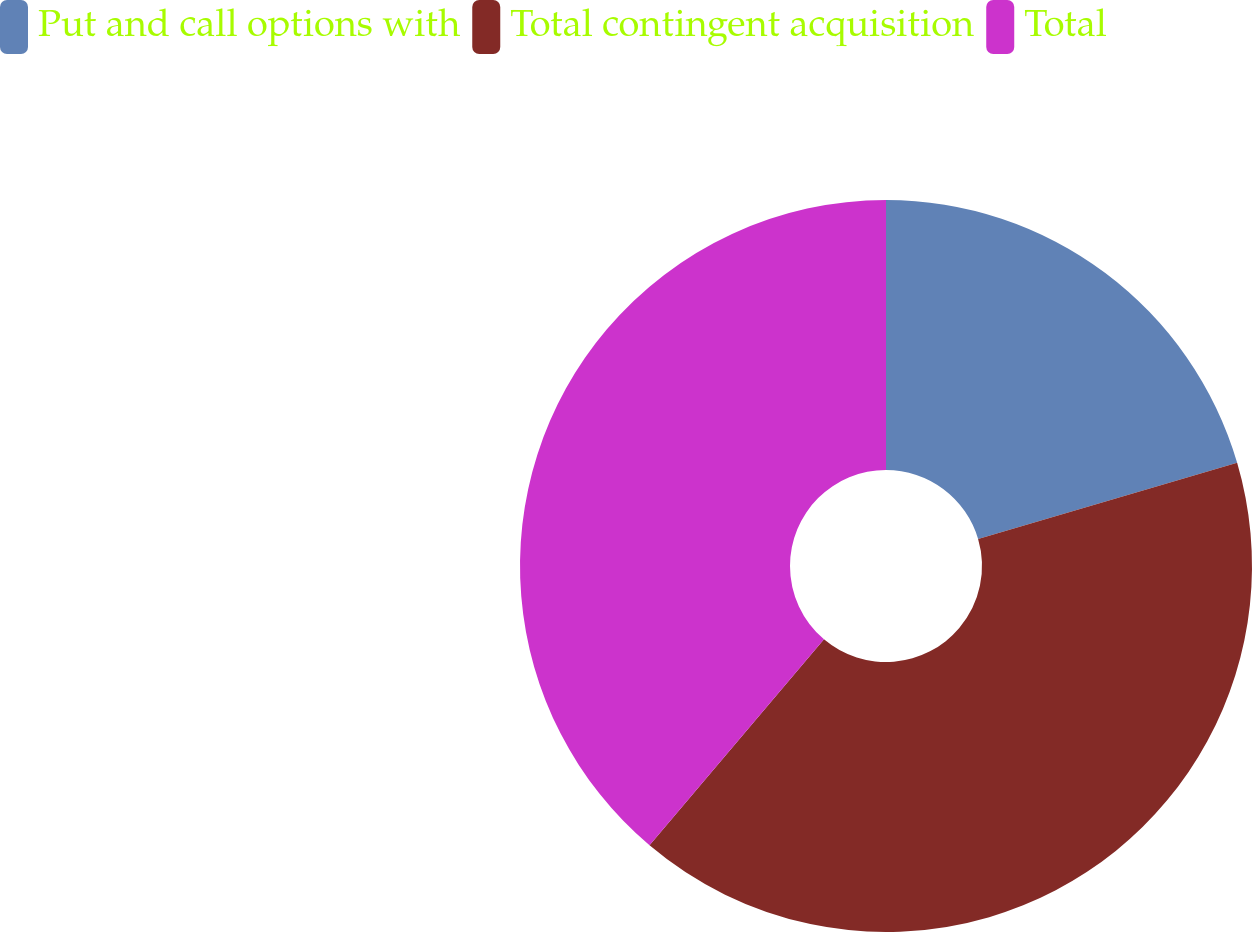Convert chart to OTSL. <chart><loc_0><loc_0><loc_500><loc_500><pie_chart><fcel>Put and call options with<fcel>Total contingent acquisition<fcel>Total<nl><fcel>20.45%<fcel>40.73%<fcel>38.82%<nl></chart> 